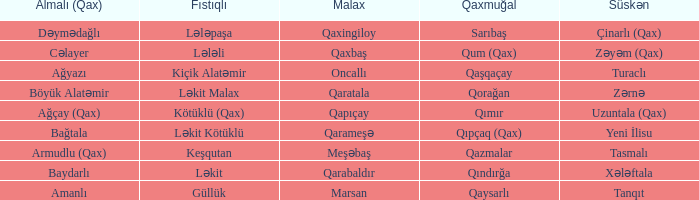What is the Qaxmuğal village with a Fistiqli village keşqutan? Qazmalar. 